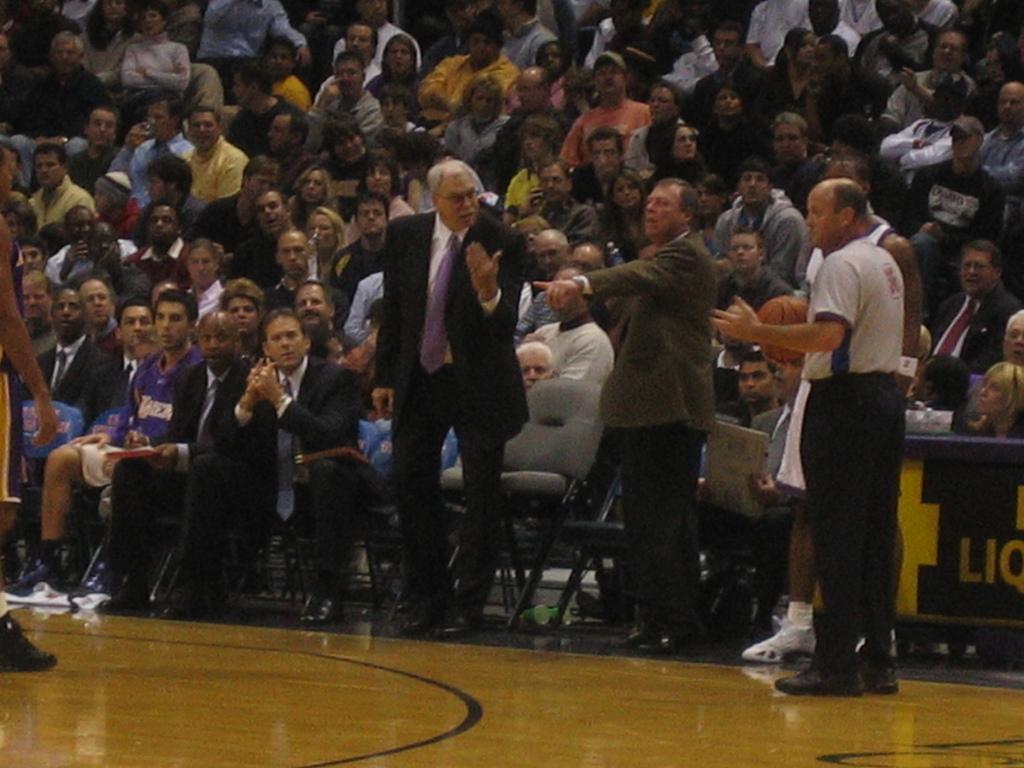In one or two sentences, can you explain what this image depicts? In the middle a man is standing, he wore a black color coat, Beside him there is another man pointing his finger, behind them there are group of people sitting on the chairs and looking at him. 